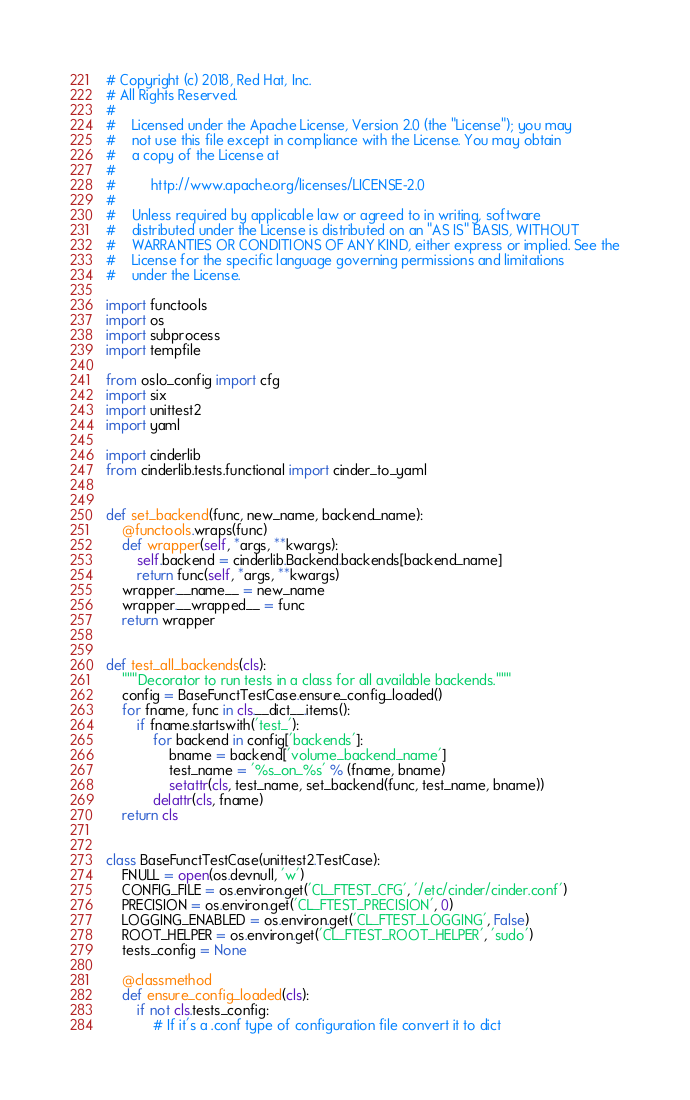Convert code to text. <code><loc_0><loc_0><loc_500><loc_500><_Python_># Copyright (c) 2018, Red Hat, Inc.
# All Rights Reserved.
#
#    Licensed under the Apache License, Version 2.0 (the "License"); you may
#    not use this file except in compliance with the License. You may obtain
#    a copy of the License at
#
#         http://www.apache.org/licenses/LICENSE-2.0
#
#    Unless required by applicable law or agreed to in writing, software
#    distributed under the License is distributed on an "AS IS" BASIS, WITHOUT
#    WARRANTIES OR CONDITIONS OF ANY KIND, either express or implied. See the
#    License for the specific language governing permissions and limitations
#    under the License.

import functools
import os
import subprocess
import tempfile

from oslo_config import cfg
import six
import unittest2
import yaml

import cinderlib
from cinderlib.tests.functional import cinder_to_yaml


def set_backend(func, new_name, backend_name):
    @functools.wraps(func)
    def wrapper(self, *args, **kwargs):
        self.backend = cinderlib.Backend.backends[backend_name]
        return func(self, *args, **kwargs)
    wrapper.__name__ = new_name
    wrapper.__wrapped__ = func
    return wrapper


def test_all_backends(cls):
    """Decorator to run tests in a class for all available backends."""
    config = BaseFunctTestCase.ensure_config_loaded()
    for fname, func in cls.__dict__.items():
        if fname.startswith('test_'):
            for backend in config['backends']:
                bname = backend['volume_backend_name']
                test_name = '%s_on_%s' % (fname, bname)
                setattr(cls, test_name, set_backend(func, test_name, bname))
            delattr(cls, fname)
    return cls


class BaseFunctTestCase(unittest2.TestCase):
    FNULL = open(os.devnull, 'w')
    CONFIG_FILE = os.environ.get('CL_FTEST_CFG', '/etc/cinder/cinder.conf')
    PRECISION = os.environ.get('CL_FTEST_PRECISION', 0)
    LOGGING_ENABLED = os.environ.get('CL_FTEST_LOGGING', False)
    ROOT_HELPER = os.environ.get('CL_FTEST_ROOT_HELPER', 'sudo')
    tests_config = None

    @classmethod
    def ensure_config_loaded(cls):
        if not cls.tests_config:
            # If it's a .conf type of configuration file convert it to dict</code> 